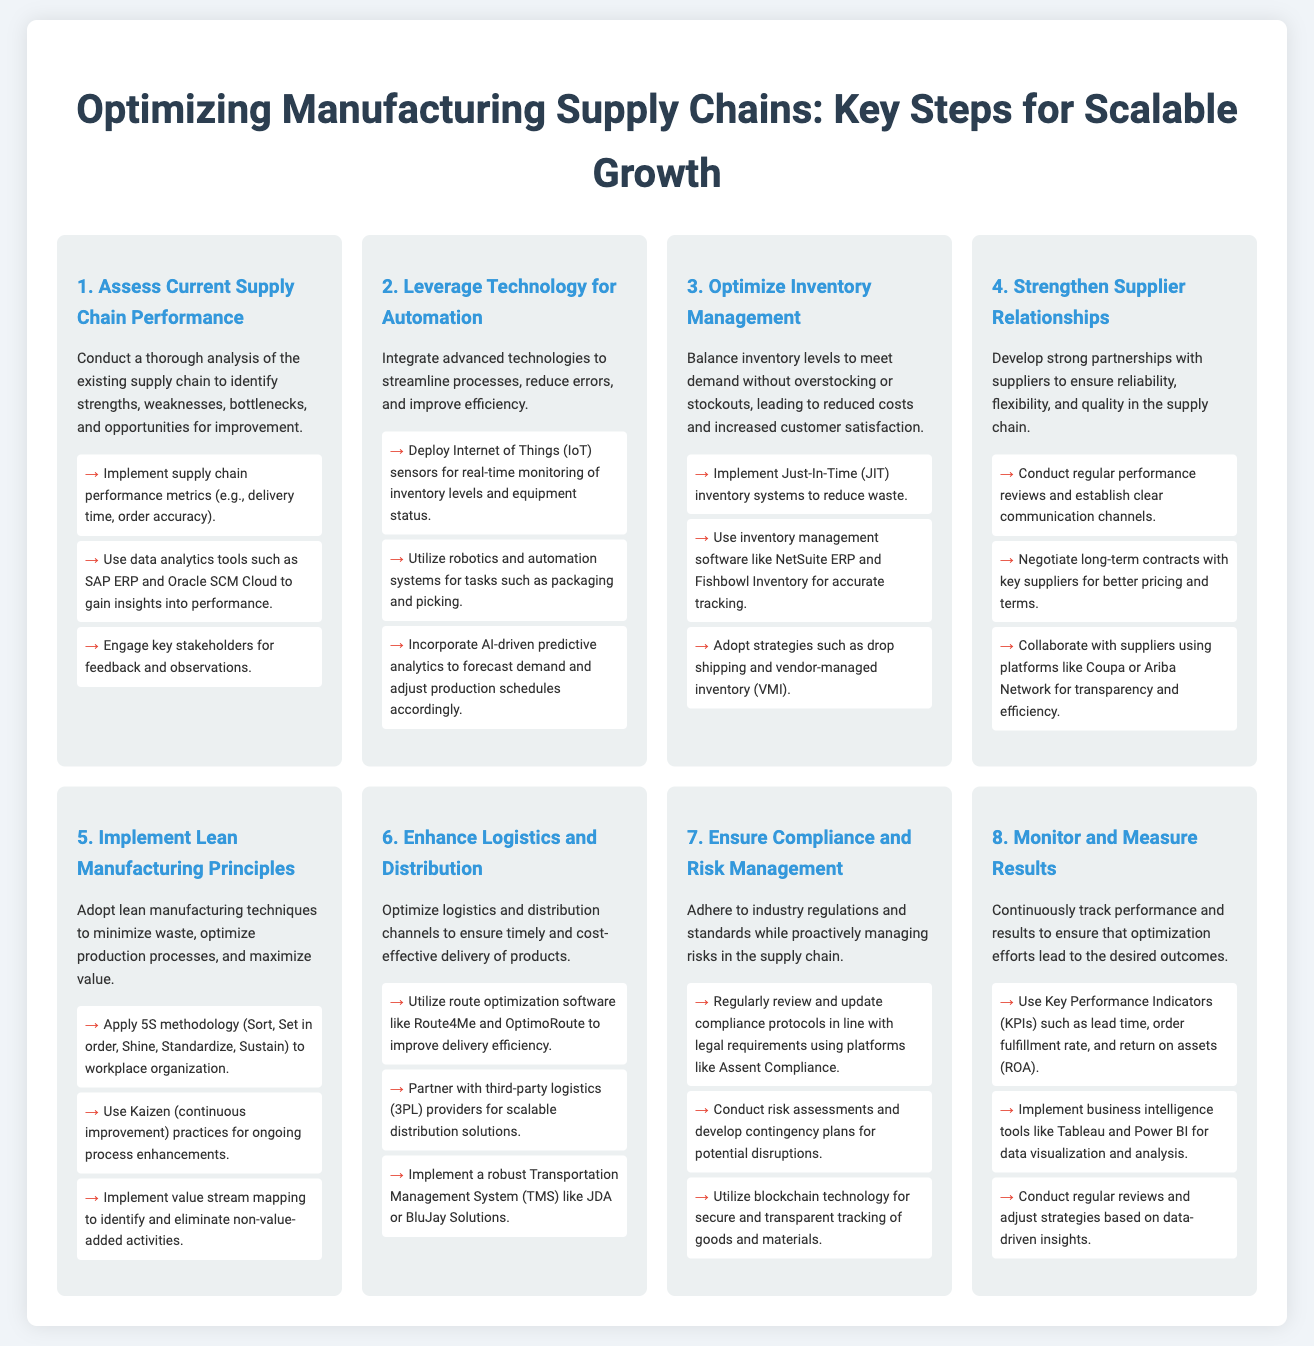What is the first step in optimizing the supply chain? The first step in optimizing the supply chain is assessing current supply chain performance.
Answer: Assess Current Supply Chain Performance What is one key action under leveraging technology for automation? One key action under leveraging technology for automation is deploying Internet of Things sensors for real-time monitoring.
Answer: Deploy IoT sensors What principle is emphasized in the fifth step? The fifth step emphasizes lean manufacturing principles.
Answer: Lean Manufacturing Principles How many steps are outlined in the process infographic? There are eight steps outlined in the process infographic.
Answer: Eight What inventory management strategy is mentioned in the third step? The inventory management strategy mentioned is Just-In-Time inventory systems.
Answer: Just-In-Time Which technology is suggested for ensuring compliance and risk management? Blockchain technology is suggested for ensuring compliance and risk management.
Answer: Blockchain technology What platform is recommended for conducting regular performance reviews with suppliers? The recommended platform for conducting regular performance reviews with suppliers is Coupa or Ariba Network.
Answer: Coupa or Ariba Network What measure is used to track the optimization results mentioned in the eighth step? Key Performance Indicators (KPIs) are used to track optimization results.
Answer: Key Performance Indicators (KPIs) 